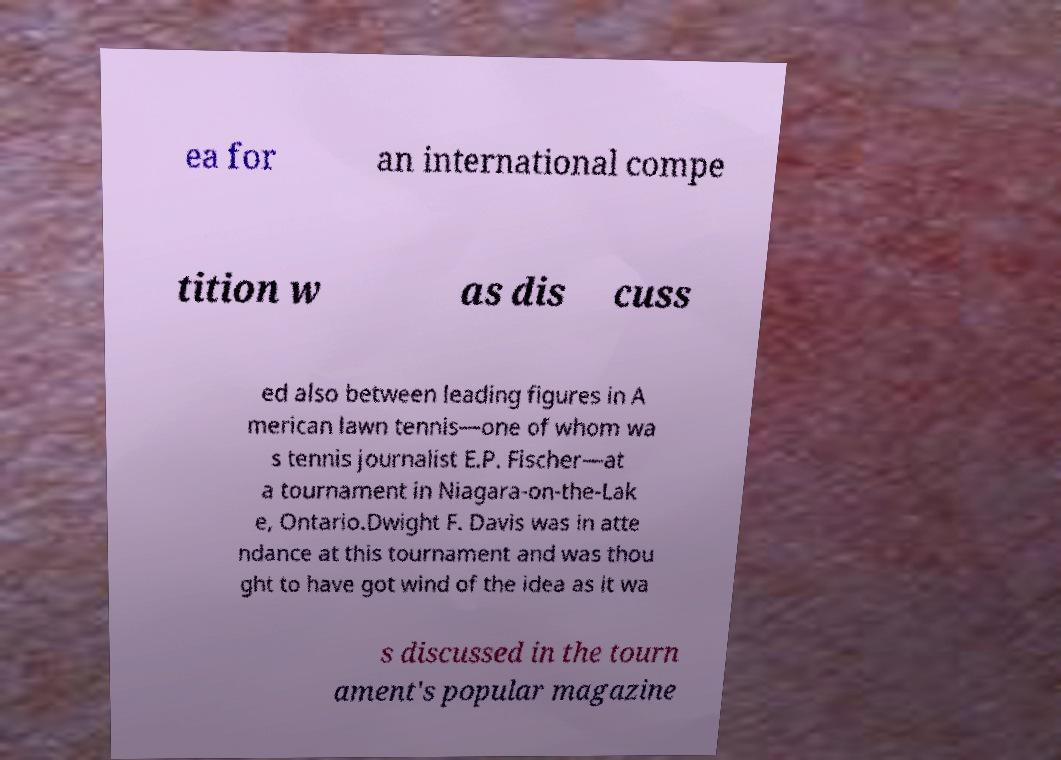Can you read and provide the text displayed in the image?This photo seems to have some interesting text. Can you extract and type it out for me? ea for an international compe tition w as dis cuss ed also between leading figures in A merican lawn tennis—one of whom wa s tennis journalist E.P. Fischer—at a tournament in Niagara-on-the-Lak e, Ontario.Dwight F. Davis was in atte ndance at this tournament and was thou ght to have got wind of the idea as it wa s discussed in the tourn ament's popular magazine 